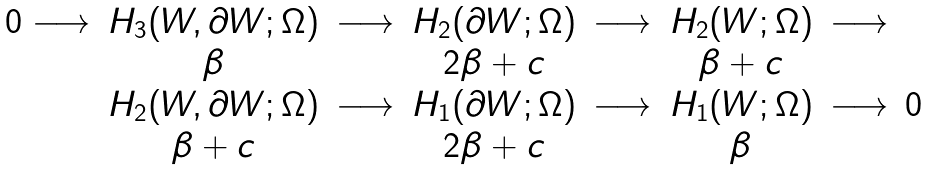<formula> <loc_0><loc_0><loc_500><loc_500>\begin{array} { c c c c c c c c c } 0 \longrightarrow & H _ { 3 } ( W , \partial W ; \Omega ) & \longrightarrow & H _ { 2 } ( \partial W ; \Omega ) & \longrightarrow & H _ { 2 } ( W ; \Omega ) & \longrightarrow \\ & \beta & & 2 \beta + c & & \beta + c & \\ & H _ { 2 } ( W , \partial W ; \Omega ) & \longrightarrow & H _ { 1 } ( \partial W ; \Omega ) & \longrightarrow & H _ { 1 } ( W ; \Omega ) & \longrightarrow & 0 \\ & \beta + c & & 2 \beta + c & & \beta & \end{array}</formula> 